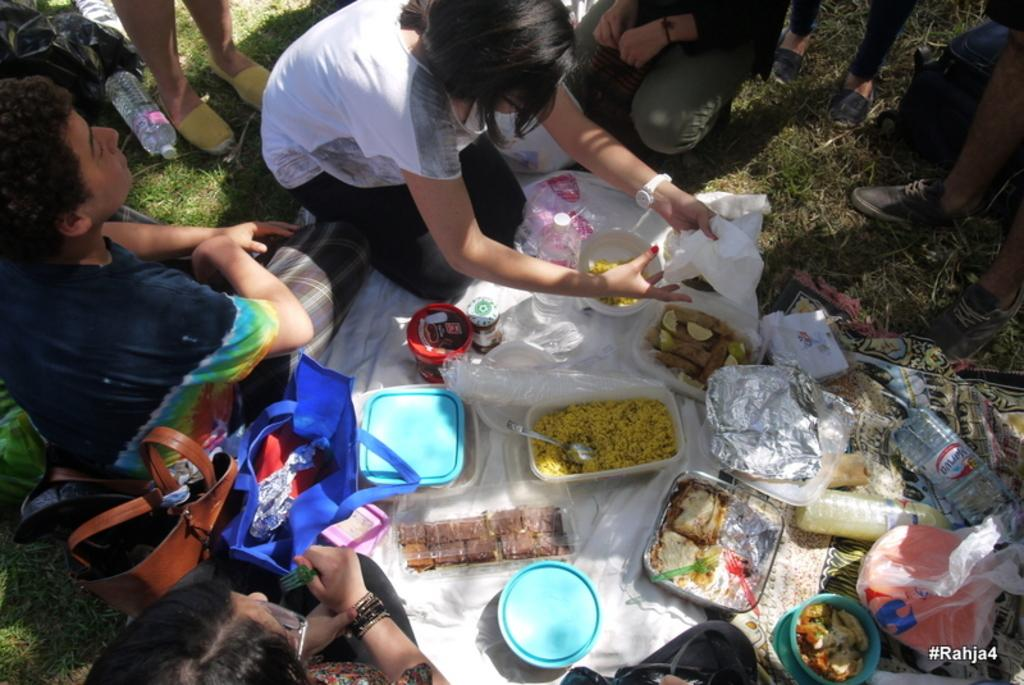What are the people in the image doing? The people in the image are sitting and standing. What objects can be seen in the image besides people? There are bags, boxes, and food items in the image. What might be used to cover or protect items in the image? There are covers in the image. What type of natural environment is visible in the image? There is grass in the image. What type of fan can be seen in the image? There is no fan present in the image. What type of eggnog is being served in the image? There is no eggnog present in the image. 